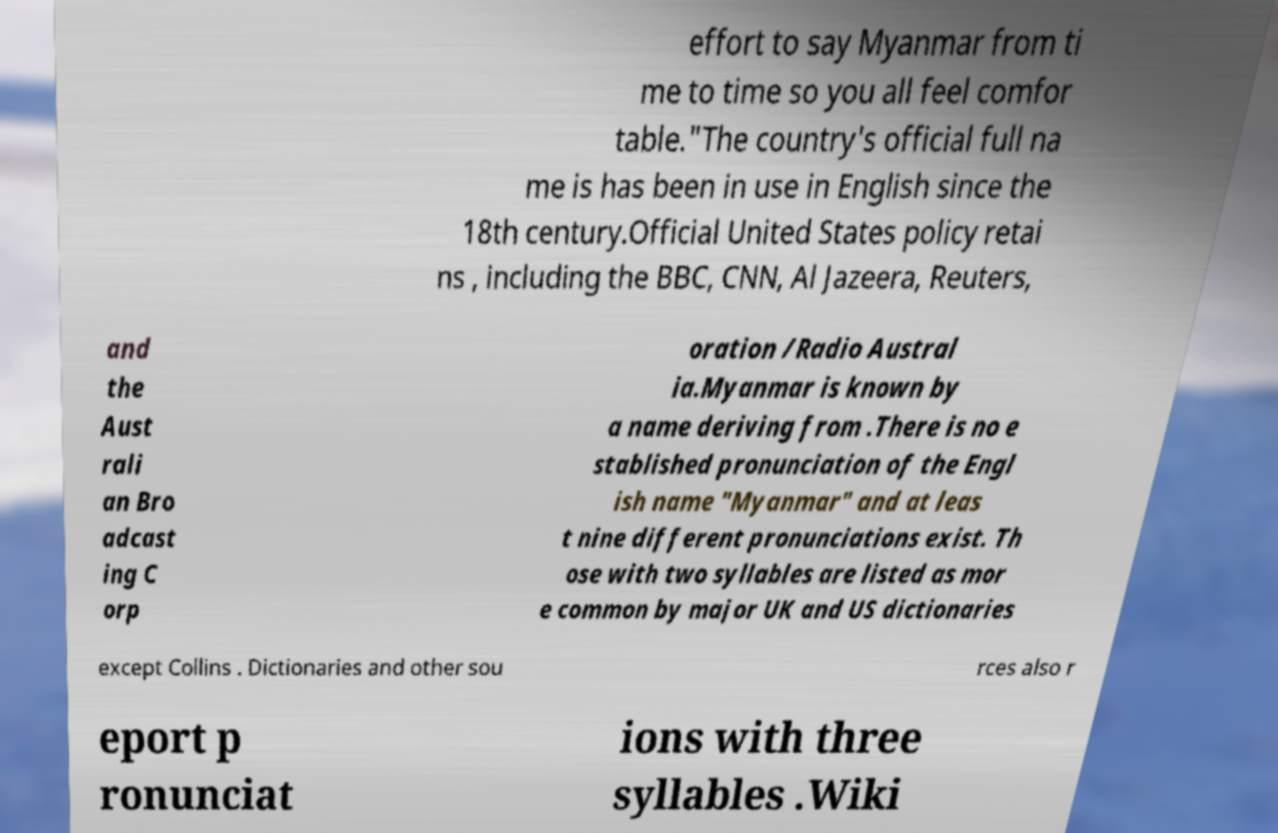I need the written content from this picture converted into text. Can you do that? effort to say Myanmar from ti me to time so you all feel comfor table."The country's official full na me is has been in use in English since the 18th century.Official United States policy retai ns , including the BBC, CNN, Al Jazeera, Reuters, and the Aust rali an Bro adcast ing C orp oration /Radio Austral ia.Myanmar is known by a name deriving from .There is no e stablished pronunciation of the Engl ish name "Myanmar" and at leas t nine different pronunciations exist. Th ose with two syllables are listed as mor e common by major UK and US dictionaries except Collins . Dictionaries and other sou rces also r eport p ronunciat ions with three syllables .Wiki 